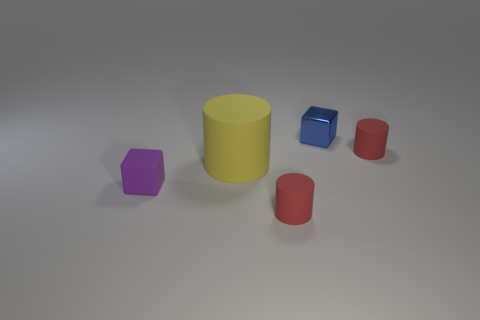Subtract all yellow cylinders. How many cylinders are left? 2 Subtract all blocks. How many objects are left? 3 Subtract all yellow cylinders. How many cylinders are left? 2 Add 1 yellow metal blocks. How many objects exist? 6 Subtract all red balls. How many red cylinders are left? 2 Subtract all tiny matte balls. Subtract all tiny matte blocks. How many objects are left? 4 Add 3 small purple objects. How many small purple objects are left? 4 Add 4 purple rubber balls. How many purple rubber balls exist? 4 Subtract 0 red cubes. How many objects are left? 5 Subtract 2 cylinders. How many cylinders are left? 1 